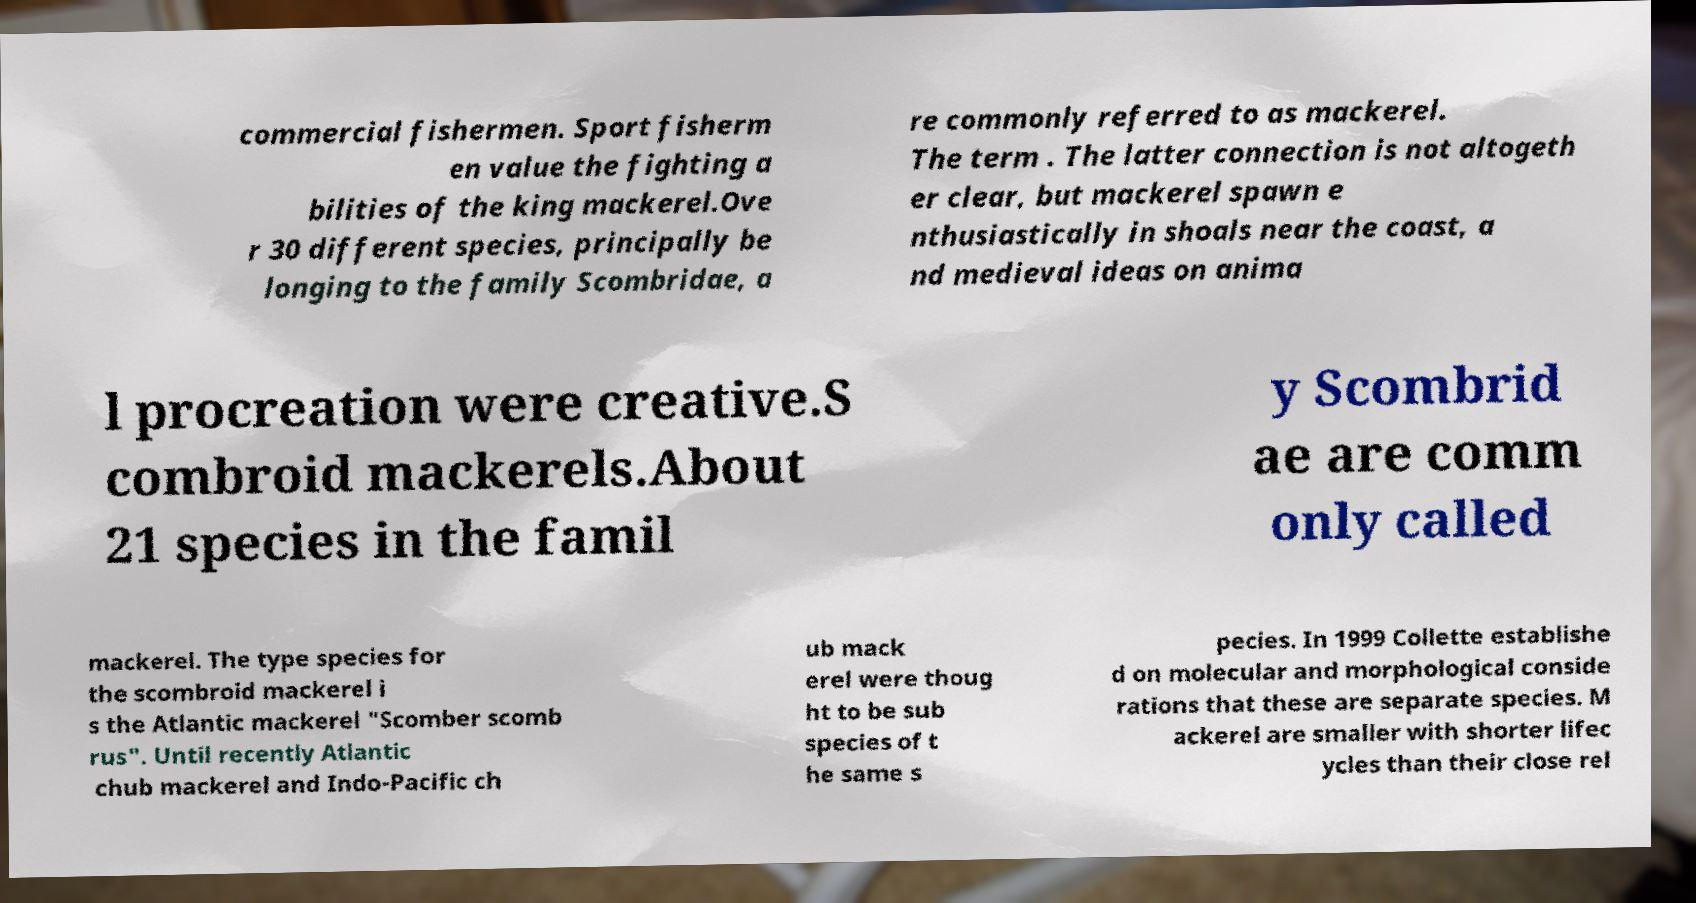Could you extract and type out the text from this image? commercial fishermen. Sport fisherm en value the fighting a bilities of the king mackerel.Ove r 30 different species, principally be longing to the family Scombridae, a re commonly referred to as mackerel. The term . The latter connection is not altogeth er clear, but mackerel spawn e nthusiastically in shoals near the coast, a nd medieval ideas on anima l procreation were creative.S combroid mackerels.About 21 species in the famil y Scombrid ae are comm only called mackerel. The type species for the scombroid mackerel i s the Atlantic mackerel "Scomber scomb rus". Until recently Atlantic chub mackerel and Indo-Pacific ch ub mack erel were thoug ht to be sub species of t he same s pecies. In 1999 Collette establishe d on molecular and morphological conside rations that these are separate species. M ackerel are smaller with shorter lifec ycles than their close rel 